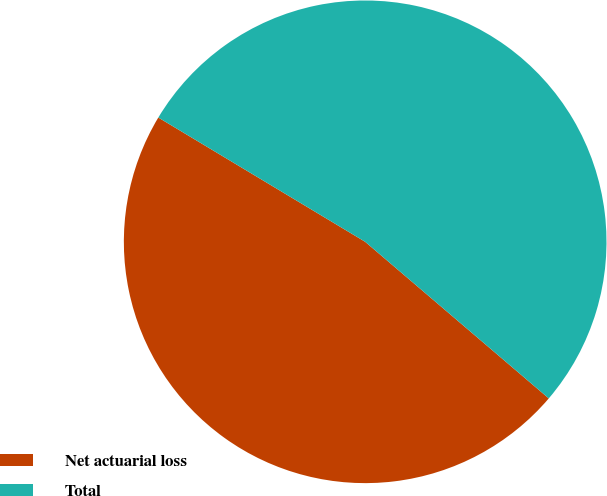<chart> <loc_0><loc_0><loc_500><loc_500><pie_chart><fcel>Net actuarial loss<fcel>Total<nl><fcel>47.37%<fcel>52.63%<nl></chart> 